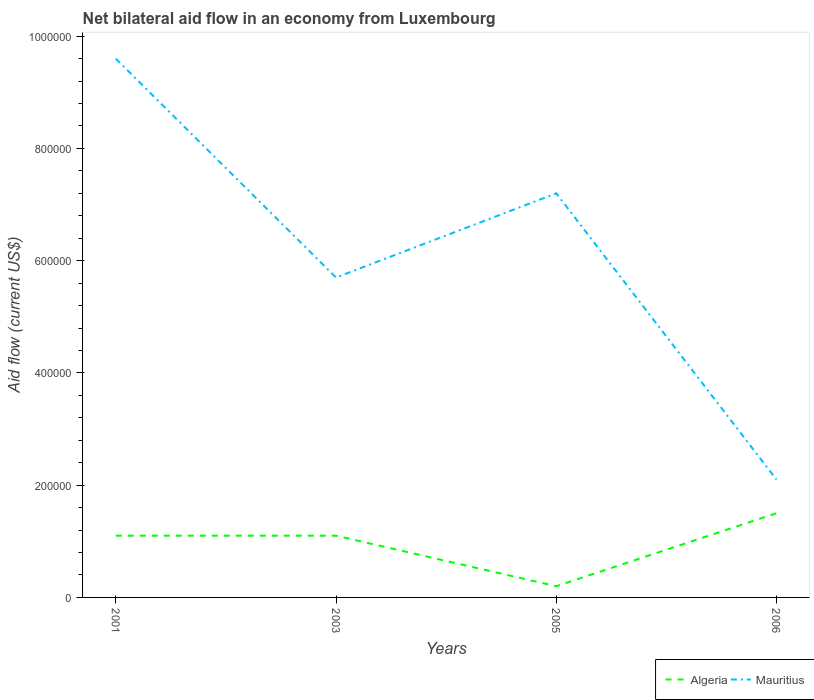How many different coloured lines are there?
Offer a terse response. 2. How many years are there in the graph?
Your answer should be compact. 4. Are the values on the major ticks of Y-axis written in scientific E-notation?
Make the answer very short. No. How many legend labels are there?
Keep it short and to the point. 2. How are the legend labels stacked?
Ensure brevity in your answer.  Horizontal. What is the title of the graph?
Provide a succinct answer. Net bilateral aid flow in an economy from Luxembourg. Does "South Sudan" appear as one of the legend labels in the graph?
Give a very brief answer. No. What is the label or title of the Y-axis?
Your answer should be compact. Aid flow (current US$). What is the Aid flow (current US$) of Mauritius in 2001?
Provide a succinct answer. 9.60e+05. What is the Aid flow (current US$) in Mauritius in 2003?
Your answer should be very brief. 5.70e+05. What is the Aid flow (current US$) of Algeria in 2005?
Keep it short and to the point. 2.00e+04. What is the Aid flow (current US$) of Mauritius in 2005?
Ensure brevity in your answer.  7.20e+05. What is the Aid flow (current US$) in Algeria in 2006?
Make the answer very short. 1.50e+05. What is the Aid flow (current US$) in Mauritius in 2006?
Give a very brief answer. 2.10e+05. Across all years, what is the maximum Aid flow (current US$) in Algeria?
Your answer should be very brief. 1.50e+05. Across all years, what is the maximum Aid flow (current US$) of Mauritius?
Give a very brief answer. 9.60e+05. Across all years, what is the minimum Aid flow (current US$) in Algeria?
Offer a very short reply. 2.00e+04. Across all years, what is the minimum Aid flow (current US$) in Mauritius?
Provide a short and direct response. 2.10e+05. What is the total Aid flow (current US$) in Mauritius in the graph?
Ensure brevity in your answer.  2.46e+06. What is the difference between the Aid flow (current US$) in Algeria in 2001 and that in 2003?
Provide a succinct answer. 0. What is the difference between the Aid flow (current US$) in Algeria in 2001 and that in 2005?
Keep it short and to the point. 9.00e+04. What is the difference between the Aid flow (current US$) in Mauritius in 2001 and that in 2006?
Make the answer very short. 7.50e+05. What is the difference between the Aid flow (current US$) of Algeria in 2003 and that in 2005?
Provide a short and direct response. 9.00e+04. What is the difference between the Aid flow (current US$) of Mauritius in 2005 and that in 2006?
Your response must be concise. 5.10e+05. What is the difference between the Aid flow (current US$) in Algeria in 2001 and the Aid flow (current US$) in Mauritius in 2003?
Your answer should be very brief. -4.60e+05. What is the difference between the Aid flow (current US$) in Algeria in 2001 and the Aid flow (current US$) in Mauritius in 2005?
Keep it short and to the point. -6.10e+05. What is the difference between the Aid flow (current US$) of Algeria in 2003 and the Aid flow (current US$) of Mauritius in 2005?
Your answer should be very brief. -6.10e+05. What is the average Aid flow (current US$) in Algeria per year?
Keep it short and to the point. 9.75e+04. What is the average Aid flow (current US$) of Mauritius per year?
Your answer should be very brief. 6.15e+05. In the year 2001, what is the difference between the Aid flow (current US$) in Algeria and Aid flow (current US$) in Mauritius?
Your response must be concise. -8.50e+05. In the year 2003, what is the difference between the Aid flow (current US$) of Algeria and Aid flow (current US$) of Mauritius?
Your response must be concise. -4.60e+05. In the year 2005, what is the difference between the Aid flow (current US$) in Algeria and Aid flow (current US$) in Mauritius?
Keep it short and to the point. -7.00e+05. In the year 2006, what is the difference between the Aid flow (current US$) of Algeria and Aid flow (current US$) of Mauritius?
Offer a terse response. -6.00e+04. What is the ratio of the Aid flow (current US$) of Mauritius in 2001 to that in 2003?
Keep it short and to the point. 1.68. What is the ratio of the Aid flow (current US$) in Mauritius in 2001 to that in 2005?
Provide a short and direct response. 1.33. What is the ratio of the Aid flow (current US$) in Algeria in 2001 to that in 2006?
Your response must be concise. 0.73. What is the ratio of the Aid flow (current US$) in Mauritius in 2001 to that in 2006?
Offer a terse response. 4.57. What is the ratio of the Aid flow (current US$) of Mauritius in 2003 to that in 2005?
Your answer should be compact. 0.79. What is the ratio of the Aid flow (current US$) of Algeria in 2003 to that in 2006?
Ensure brevity in your answer.  0.73. What is the ratio of the Aid flow (current US$) of Mauritius in 2003 to that in 2006?
Provide a succinct answer. 2.71. What is the ratio of the Aid flow (current US$) in Algeria in 2005 to that in 2006?
Your answer should be very brief. 0.13. What is the ratio of the Aid flow (current US$) in Mauritius in 2005 to that in 2006?
Offer a very short reply. 3.43. What is the difference between the highest and the lowest Aid flow (current US$) of Mauritius?
Give a very brief answer. 7.50e+05. 